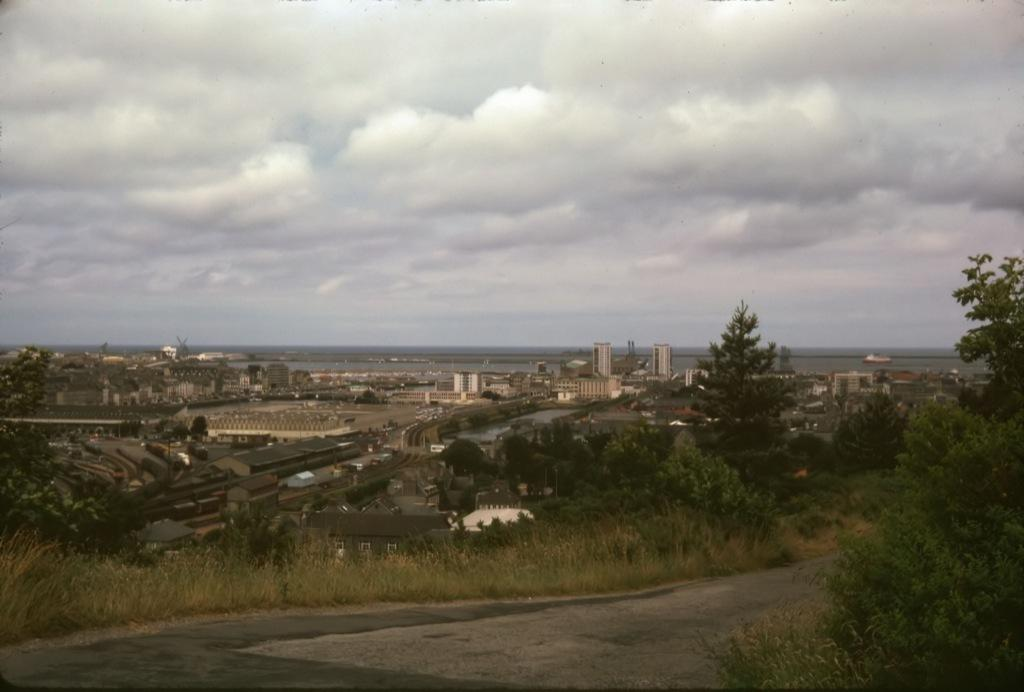What type of man-made structure can be seen in the image? There are buildings in the image. What natural elements are present in the image? There are trees in the image. What is the primary mode of transportation visible in the image? The road in the image suggests that vehicles might be used for transportation. What is visible in the sky at the top of the image? Clouds are visible in the sky at the top of the image. Where is the bomb located in the image? There is no bomb present in the image. What type of plantation can be seen in the image? There is no plantation present in the image. 